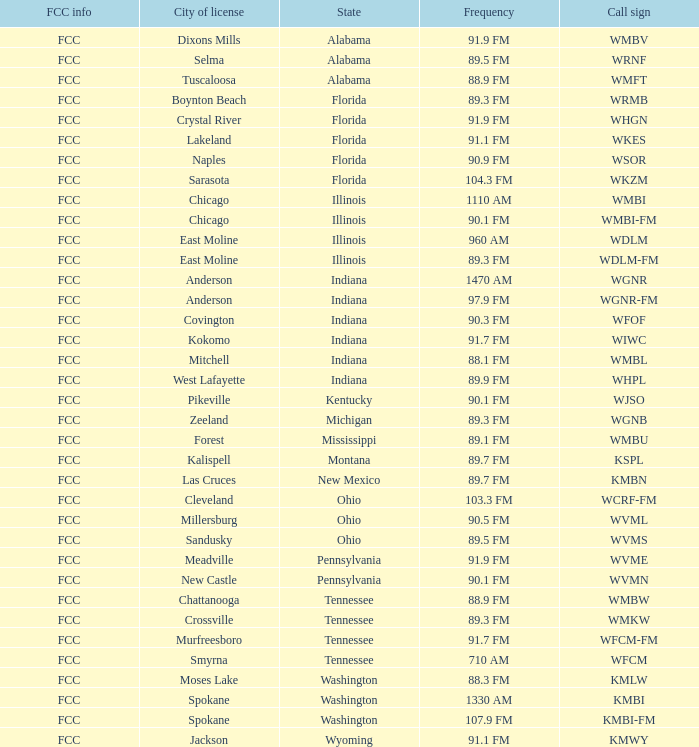What city is 103.3 FM licensed in? Cleveland. 